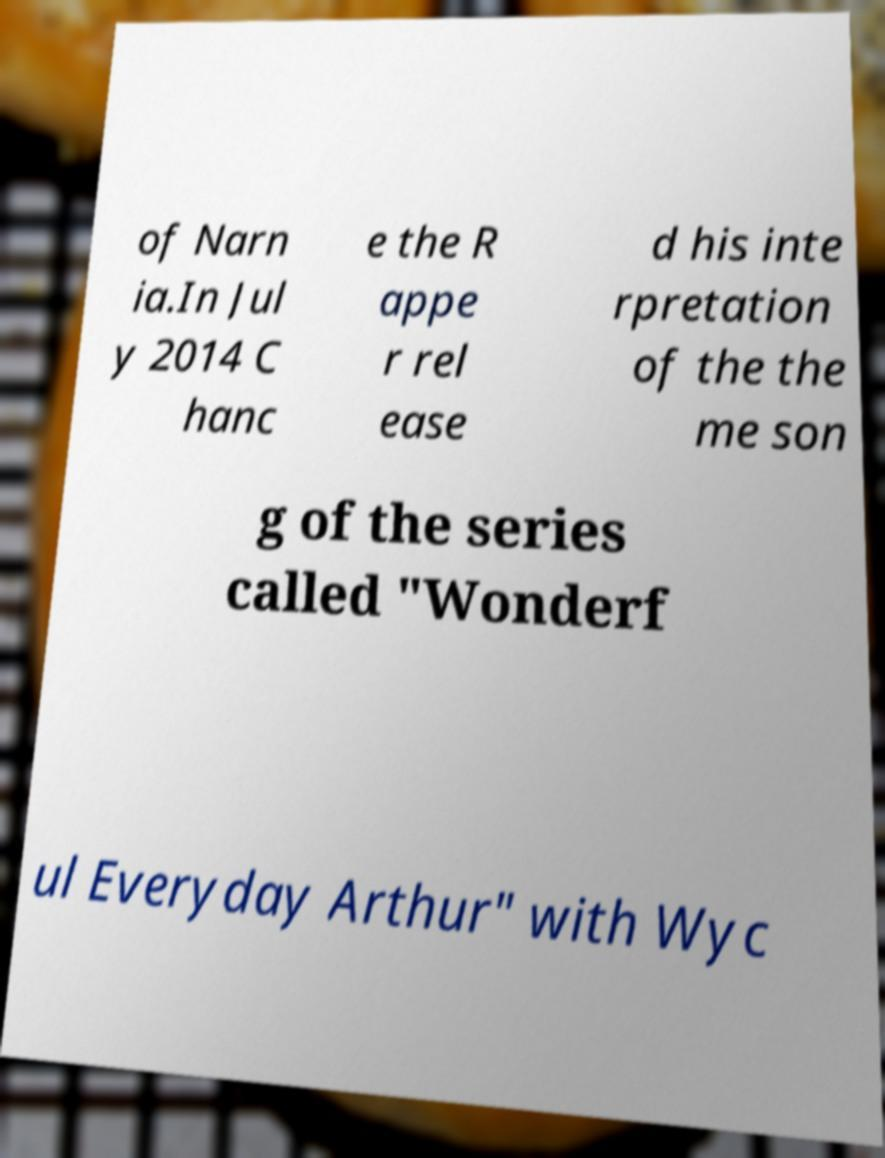What messages or text are displayed in this image? I need them in a readable, typed format. of Narn ia.In Jul y 2014 C hanc e the R appe r rel ease d his inte rpretation of the the me son g of the series called "Wonderf ul Everyday Arthur" with Wyc 